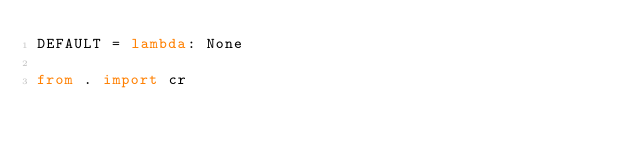<code> <loc_0><loc_0><loc_500><loc_500><_Python_>DEFAULT = lambda: None

from . import cr
</code> 